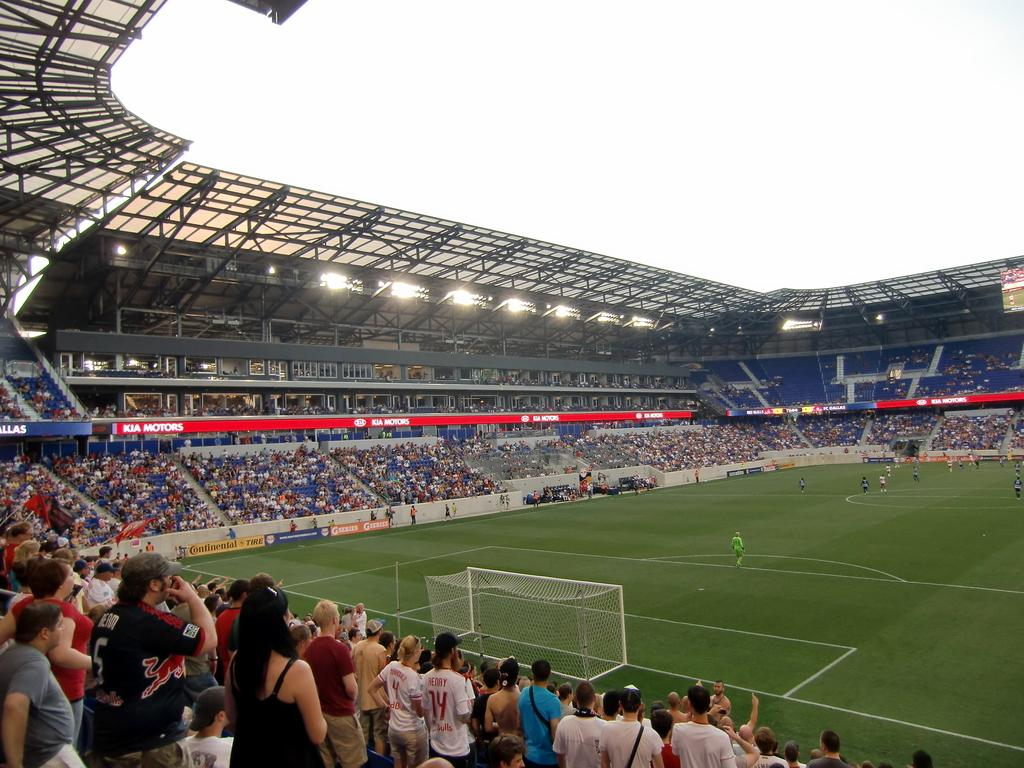<image>
Summarize the visual content of the image. Soccer Field with Kia Motors advertisement in the background. 